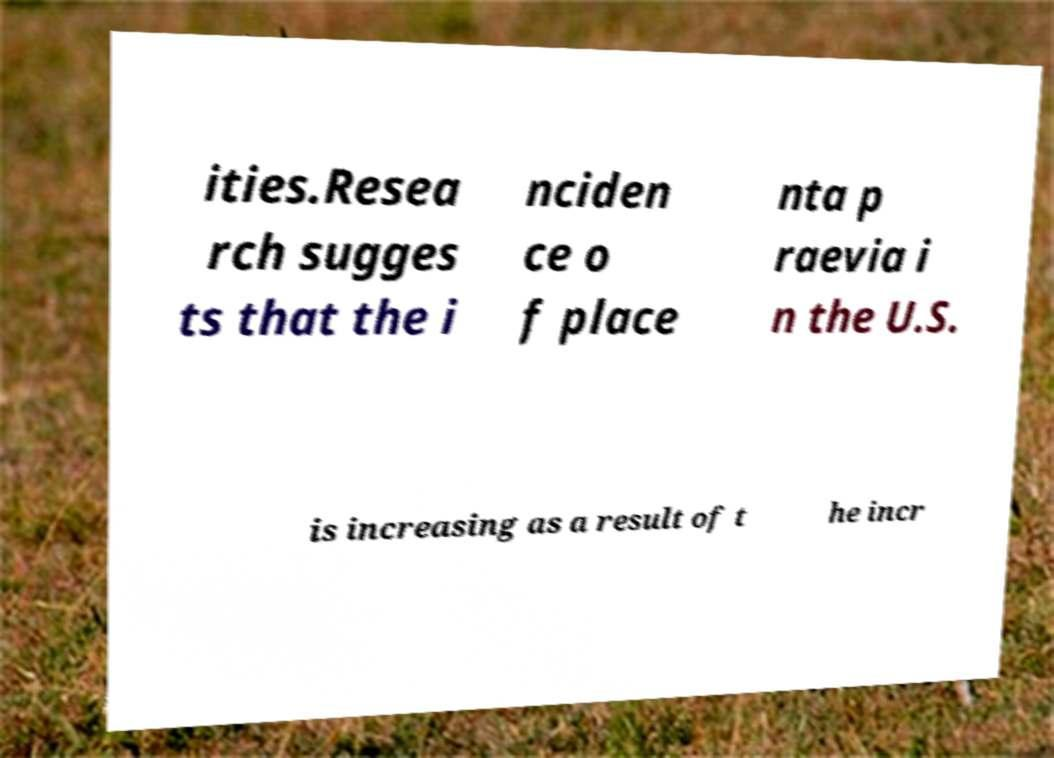Could you extract and type out the text from this image? ities.Resea rch sugges ts that the i nciden ce o f place nta p raevia i n the U.S. is increasing as a result of t he incr 